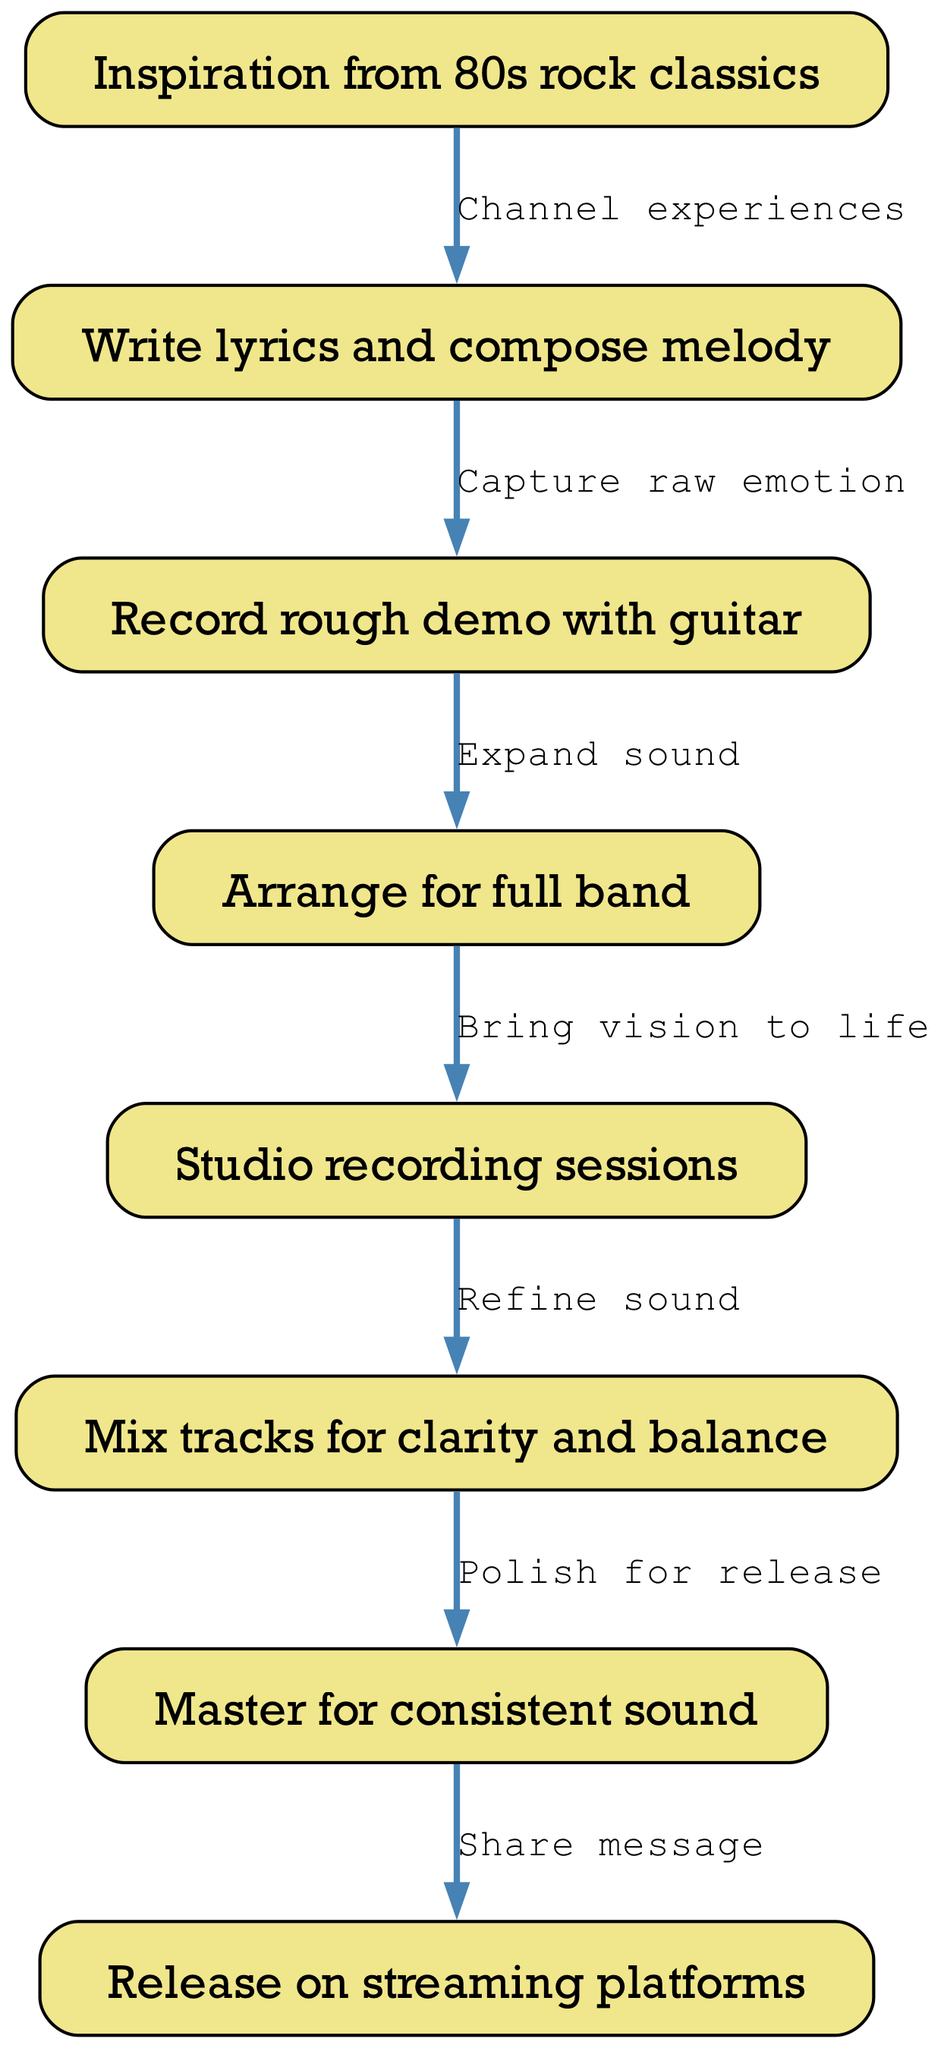What is the first step in the music production workflow? The first step is represented by the "start" node labeled, "Inspiration from 80s rock classics." This is the initial point in the flowchart, showing what inspires the entire process.
Answer: Inspiration from 80s rock classics How many total nodes are in the diagram? The diagram contains eight nodes, which are each labeled with different steps in the music production workflow. Counting these nodes gives a total of eight.
Answer: 8 What is the last step before releasing the music? The last step before releasing the music is "Master for consistent sound." This is the process just prior to the final release node, preparing the music for distribution.
Answer: Master for consistent sound Which node follows the "studio recording sessions" node? The node that follows "studio recording sessions" is "Mix tracks for clarity and balance." This signifies the next logical step in the workflow after recording.
Answer: Mix tracks for clarity and balance What is the relationship between the "arrangement" and "recording" nodes? The relationship between these nodes is represented by an edge stating, "Bring vision to life." This phrase explains that arrangement is directly linked to proceeding to studio recording sessions.
Answer: Bring vision to life How many edges are there in total? The diagram has a total of seven edges, which connect the various nodes and represent the progression through the workflow. Counting each edge gives the total.
Answer: 7 What should you do after recording the rough demo? After recording the rough demo, the next step is to "Arrange for full band." This indicates the workflow progression from demo to arrangement.
Answer: Arrange for full band What emotion is captured during the "songwriting" process? The emotion captured during the "songwriting" process is "raw emotion." This highlights the importance of infusing genuine feelings into the lyrics and melody creation.
Answer: raw emotion Which node is connected to the "Master for consistent sound" node? The node connected to "Master for consistent sound" is "Release on streaming platforms." This shows the final output stage of the music production workflow after mastering.
Answer: Release on streaming platforms 